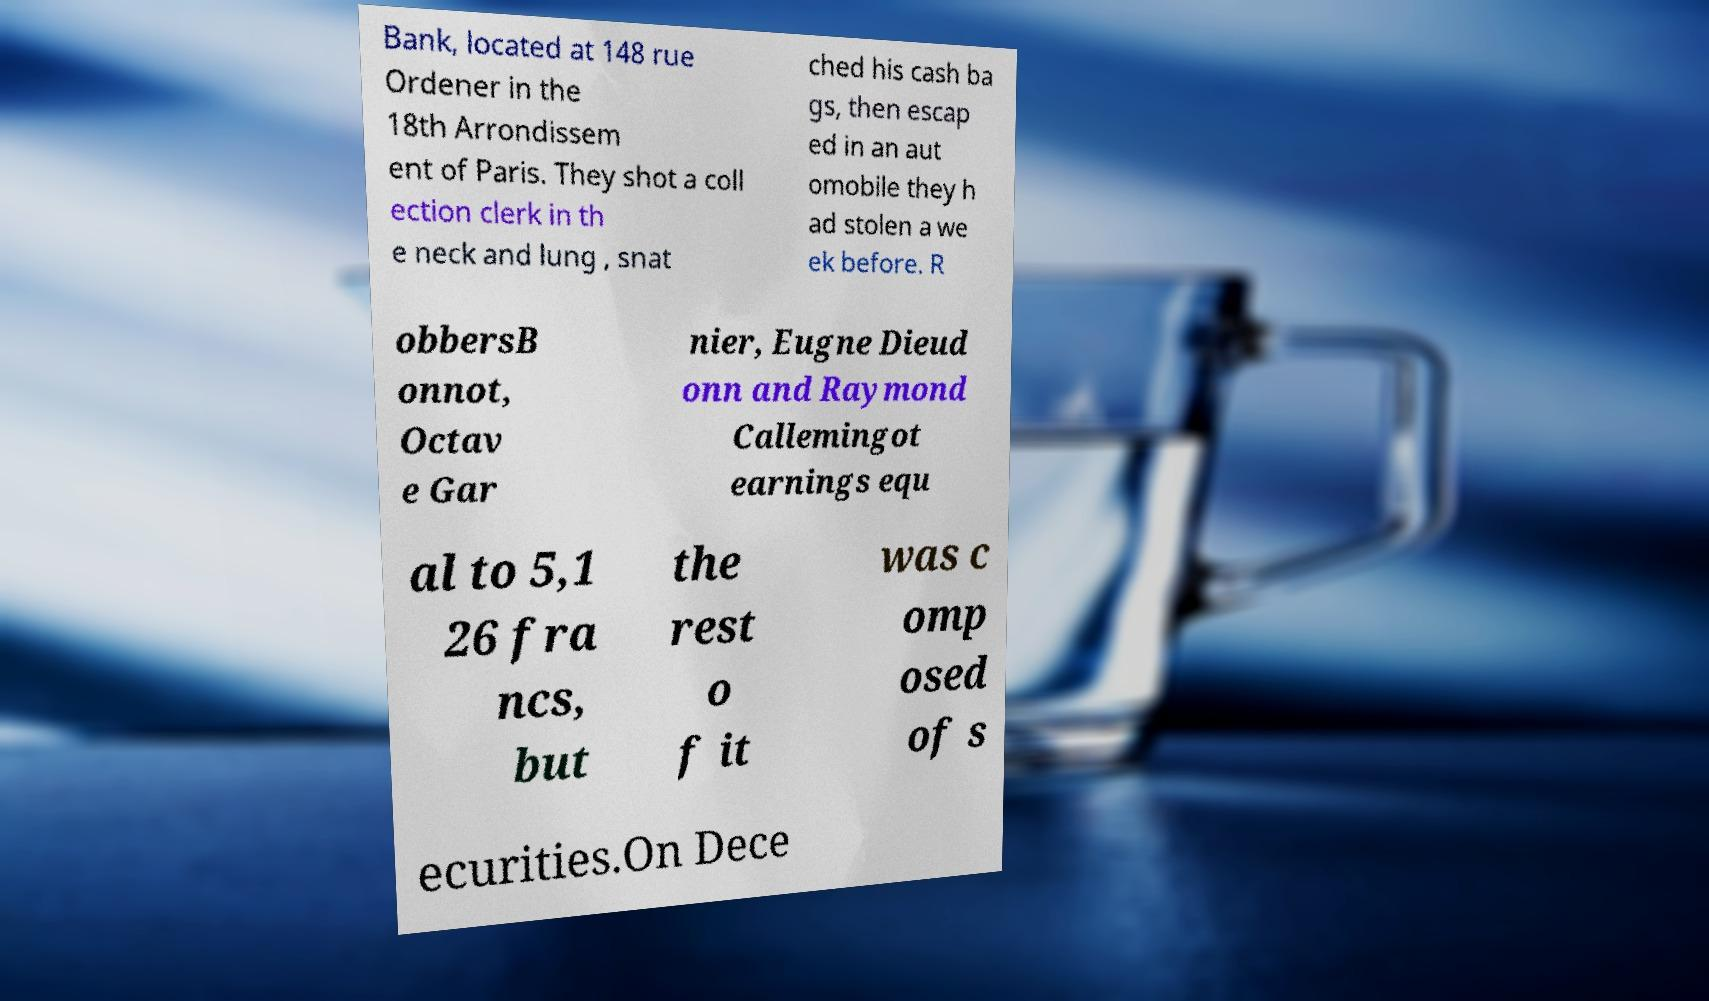Please read and relay the text visible in this image. What does it say? Bank, located at 148 rue Ordener in the 18th Arrondissem ent of Paris. They shot a coll ection clerk in th e neck and lung , snat ched his cash ba gs, then escap ed in an aut omobile they h ad stolen a we ek before. R obbersB onnot, Octav e Gar nier, Eugne Dieud onn and Raymond Callemingot earnings equ al to 5,1 26 fra ncs, but the rest o f it was c omp osed of s ecurities.On Dece 